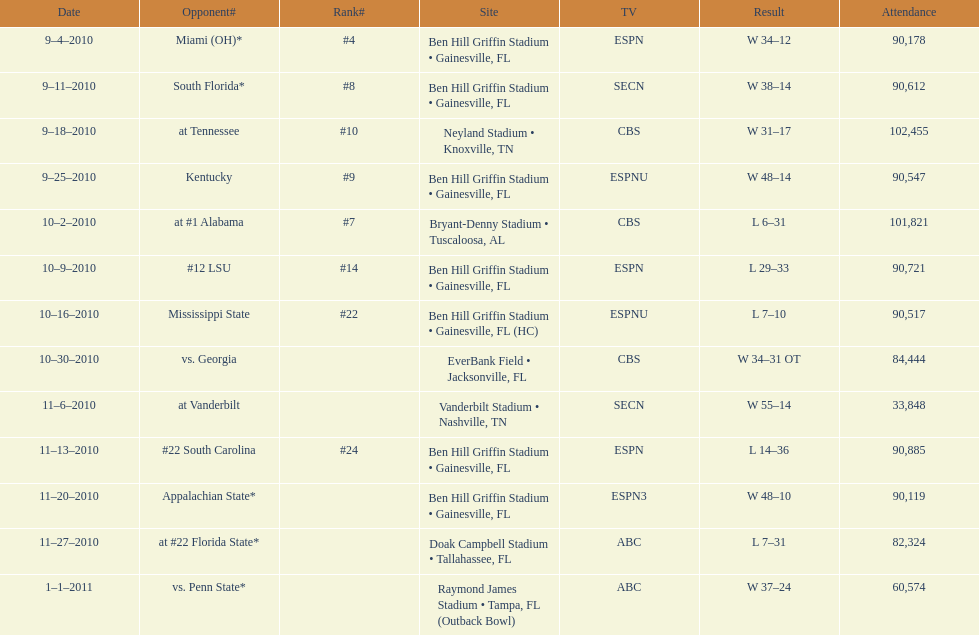In the 2010-2011 season, what was the count of games that took place at ben hill griffin stadium? 7. 